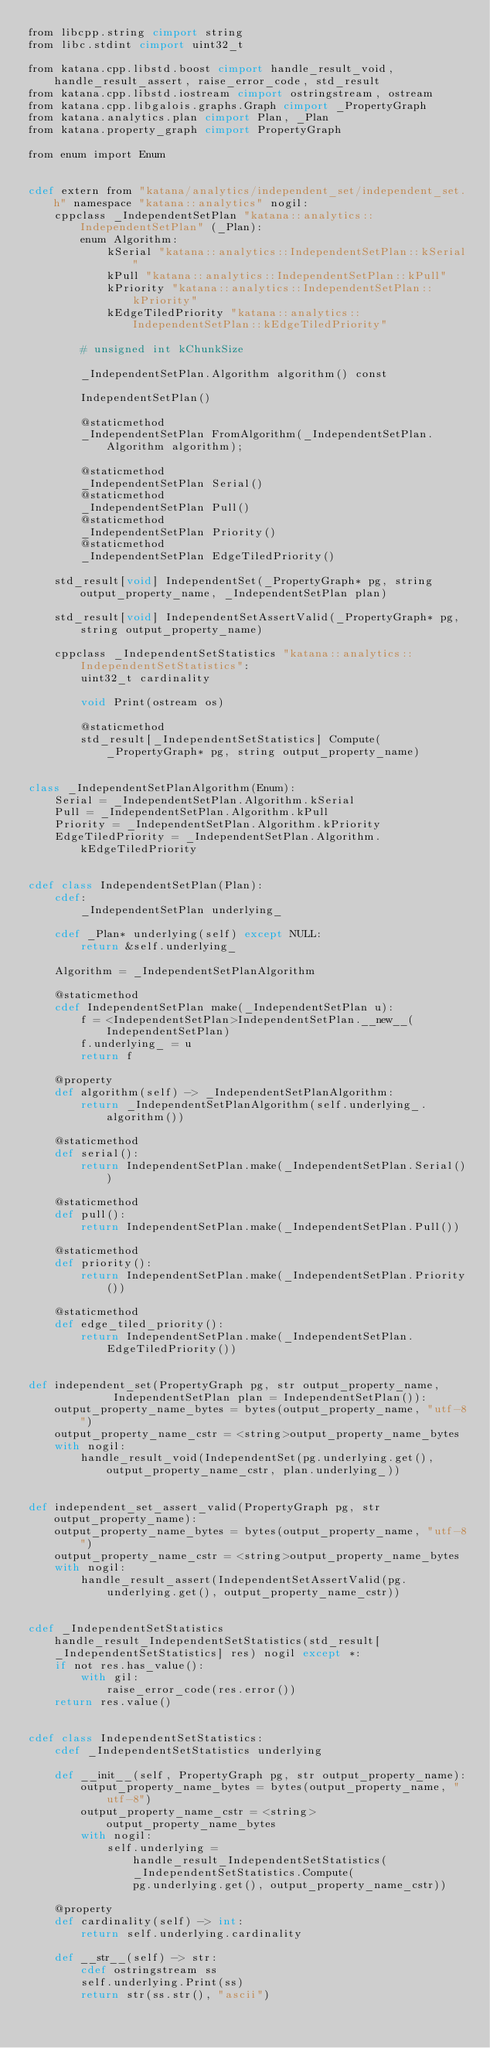<code> <loc_0><loc_0><loc_500><loc_500><_Cython_>from libcpp.string cimport string
from libc.stdint cimport uint32_t

from katana.cpp.libstd.boost cimport handle_result_void, handle_result_assert, raise_error_code, std_result
from katana.cpp.libstd.iostream cimport ostringstream, ostream
from katana.cpp.libgalois.graphs.Graph cimport _PropertyGraph
from katana.analytics.plan cimport Plan, _Plan
from katana.property_graph cimport PropertyGraph

from enum import Enum


cdef extern from "katana/analytics/independent_set/independent_set.h" namespace "katana::analytics" nogil:
    cppclass _IndependentSetPlan "katana::analytics::IndependentSetPlan" (_Plan):
        enum Algorithm:
            kSerial "katana::analytics::IndependentSetPlan::kSerial"
            kPull "katana::analytics::IndependentSetPlan::kPull"
            kPriority "katana::analytics::IndependentSetPlan::kPriority"
            kEdgeTiledPriority "katana::analytics::IndependentSetPlan::kEdgeTiledPriority"

        # unsigned int kChunkSize

        _IndependentSetPlan.Algorithm algorithm() const

        IndependentSetPlan()

        @staticmethod
        _IndependentSetPlan FromAlgorithm(_IndependentSetPlan.Algorithm algorithm);

        @staticmethod
        _IndependentSetPlan Serial()
        @staticmethod
        _IndependentSetPlan Pull()
        @staticmethod
        _IndependentSetPlan Priority()
        @staticmethod
        _IndependentSetPlan EdgeTiledPriority()

    std_result[void] IndependentSet(_PropertyGraph* pg, string output_property_name, _IndependentSetPlan plan)

    std_result[void] IndependentSetAssertValid(_PropertyGraph* pg, string output_property_name)

    cppclass _IndependentSetStatistics "katana::analytics::IndependentSetStatistics":
        uint32_t cardinality

        void Print(ostream os)

        @staticmethod
        std_result[_IndependentSetStatistics] Compute(_PropertyGraph* pg, string output_property_name)


class _IndependentSetPlanAlgorithm(Enum):
    Serial = _IndependentSetPlan.Algorithm.kSerial
    Pull = _IndependentSetPlan.Algorithm.kPull
    Priority = _IndependentSetPlan.Algorithm.kPriority
    EdgeTiledPriority = _IndependentSetPlan.Algorithm.kEdgeTiledPriority


cdef class IndependentSetPlan(Plan):
    cdef:
        _IndependentSetPlan underlying_

    cdef _Plan* underlying(self) except NULL:
        return &self.underlying_

    Algorithm = _IndependentSetPlanAlgorithm

    @staticmethod
    cdef IndependentSetPlan make(_IndependentSetPlan u):
        f = <IndependentSetPlan>IndependentSetPlan.__new__(IndependentSetPlan)
        f.underlying_ = u
        return f

    @property
    def algorithm(self) -> _IndependentSetPlanAlgorithm:
        return _IndependentSetPlanAlgorithm(self.underlying_.algorithm())

    @staticmethod
    def serial():
        return IndependentSetPlan.make(_IndependentSetPlan.Serial())

    @staticmethod
    def pull():
        return IndependentSetPlan.make(_IndependentSetPlan.Pull())

    @staticmethod
    def priority():
        return IndependentSetPlan.make(_IndependentSetPlan.Priority())

    @staticmethod
    def edge_tiled_priority():
        return IndependentSetPlan.make(_IndependentSetPlan.EdgeTiledPriority())


def independent_set(PropertyGraph pg, str output_property_name,
             IndependentSetPlan plan = IndependentSetPlan()):
    output_property_name_bytes = bytes(output_property_name, "utf-8")
    output_property_name_cstr = <string>output_property_name_bytes
    with nogil:
        handle_result_void(IndependentSet(pg.underlying.get(), output_property_name_cstr, plan.underlying_))


def independent_set_assert_valid(PropertyGraph pg, str output_property_name):
    output_property_name_bytes = bytes(output_property_name, "utf-8")
    output_property_name_cstr = <string>output_property_name_bytes
    with nogil:
        handle_result_assert(IndependentSetAssertValid(pg.underlying.get(), output_property_name_cstr))


cdef _IndependentSetStatistics handle_result_IndependentSetStatistics(std_result[_IndependentSetStatistics] res) nogil except *:
    if not res.has_value():
        with gil:
            raise_error_code(res.error())
    return res.value()


cdef class IndependentSetStatistics:
    cdef _IndependentSetStatistics underlying

    def __init__(self, PropertyGraph pg, str output_property_name):
        output_property_name_bytes = bytes(output_property_name, "utf-8")
        output_property_name_cstr = <string> output_property_name_bytes
        with nogil:
            self.underlying = handle_result_IndependentSetStatistics(_IndependentSetStatistics.Compute(
                pg.underlying.get(), output_property_name_cstr))

    @property
    def cardinality(self) -> int:
        return self.underlying.cardinality

    def __str__(self) -> str:
        cdef ostringstream ss
        self.underlying.Print(ss)
        return str(ss.str(), "ascii")
</code> 